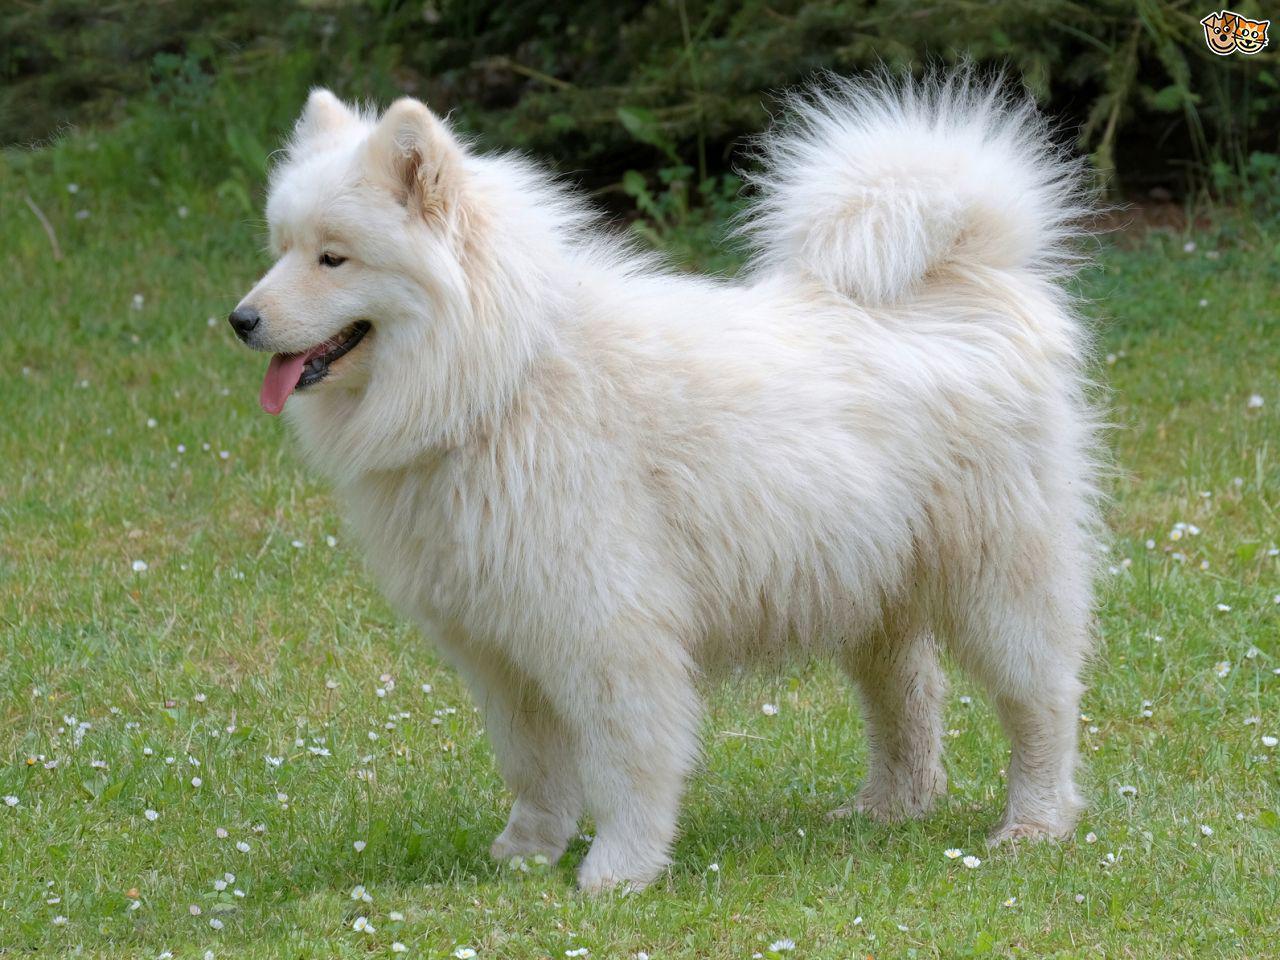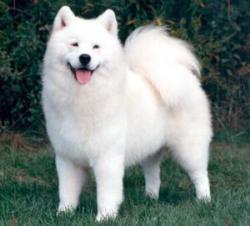The first image is the image on the left, the second image is the image on the right. Analyze the images presented: Is the assertion "One dog is facing the right and one dog is facing the left." valid? Answer yes or no. No. 